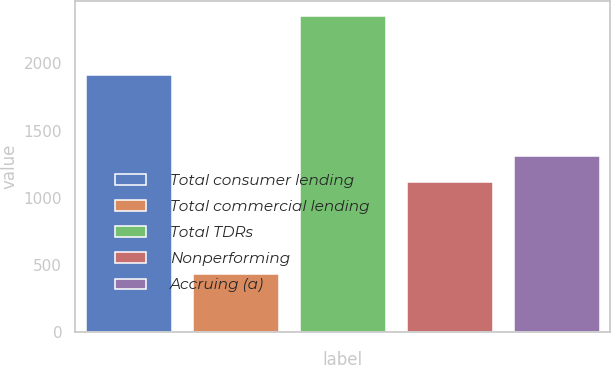Convert chart. <chart><loc_0><loc_0><loc_500><loc_500><bar_chart><fcel>Total consumer lending<fcel>Total commercial lending<fcel>Total TDRs<fcel>Nonperforming<fcel>Accruing (a)<nl><fcel>1917<fcel>434<fcel>2351<fcel>1119<fcel>1310.7<nl></chart> 